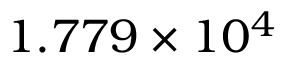Convert formula to latex. <formula><loc_0><loc_0><loc_500><loc_500>1 . 7 7 9 \times 1 0 ^ { 4 }</formula> 